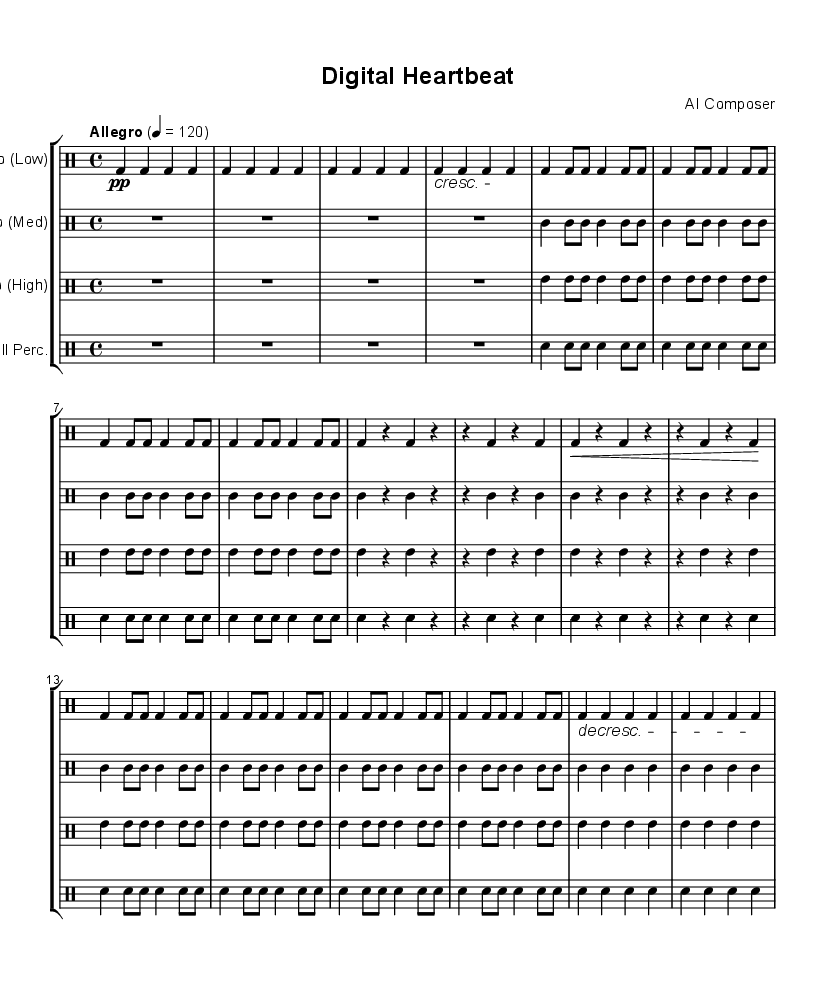What is the key signature of this music? The key signature is C major, which has no sharps or flats, as indicated by the global section of the code.
Answer: C major What is the time signature of this music? The time signature is 4/4, clearly defined in the global section of the code with the \time command.
Answer: 4/4 What is the tempo marking for this piece? The tempo marking indicates "Allegro" with a metronome setting of 120 beats per minute, as stated in the tempo line of the global section.
Answer: Allegro, 120 How many times is the main theme repeated in the taikoLow part? The main theme in the taikoLow part is repeated 4 times, as indicated by the \repeat unfold command in the code for that section.
Answer: 4 In the taikoMed part, what is the duration of the first introduction? The introduction consists of a single whole note (R1), which spans 4 beats, as defined in the taikoMed section.
Answer: Whole note What does the crescendo marking indicate in the taikoLow section? The crescendo marking means to gradually increase the volume, signifying an emotional build-up as the section progresses, seen in the crescendo notation in the score.
Answer: Gradually increase volume How many different types of percussion instruments are used in this composition? The composition features four types of percussion instruments: Taiko (Low), Taiko (Medium), Taiko (High), and Small Percussion. Each is represented by a separate drum staff in the score.
Answer: Four 